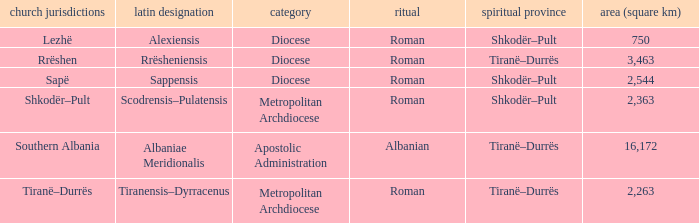What Area (km 2) is lowest with a type being Apostolic Administration? 16172.0. 